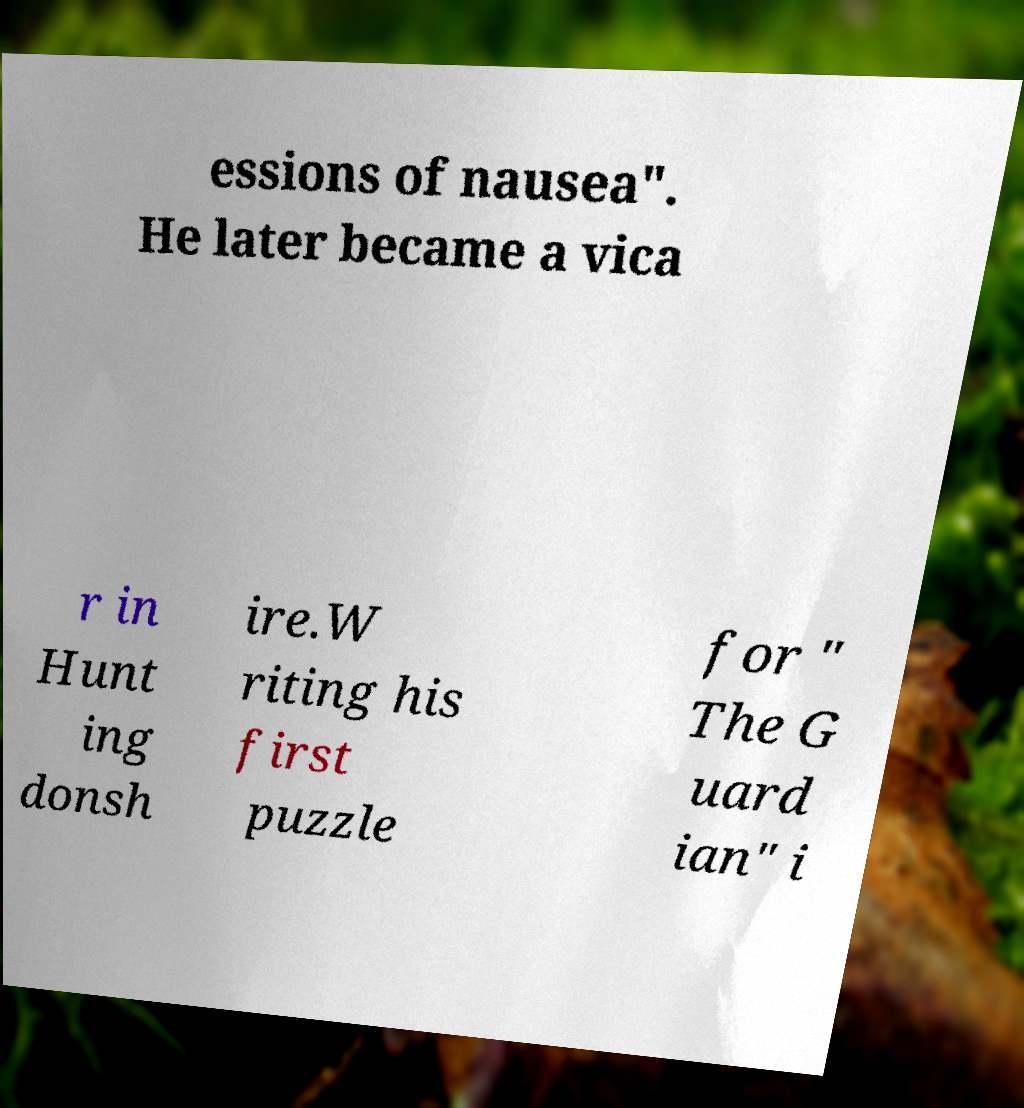Can you read and provide the text displayed in the image?This photo seems to have some interesting text. Can you extract and type it out for me? essions of nausea". He later became a vica r in Hunt ing donsh ire.W riting his first puzzle for " The G uard ian" i 